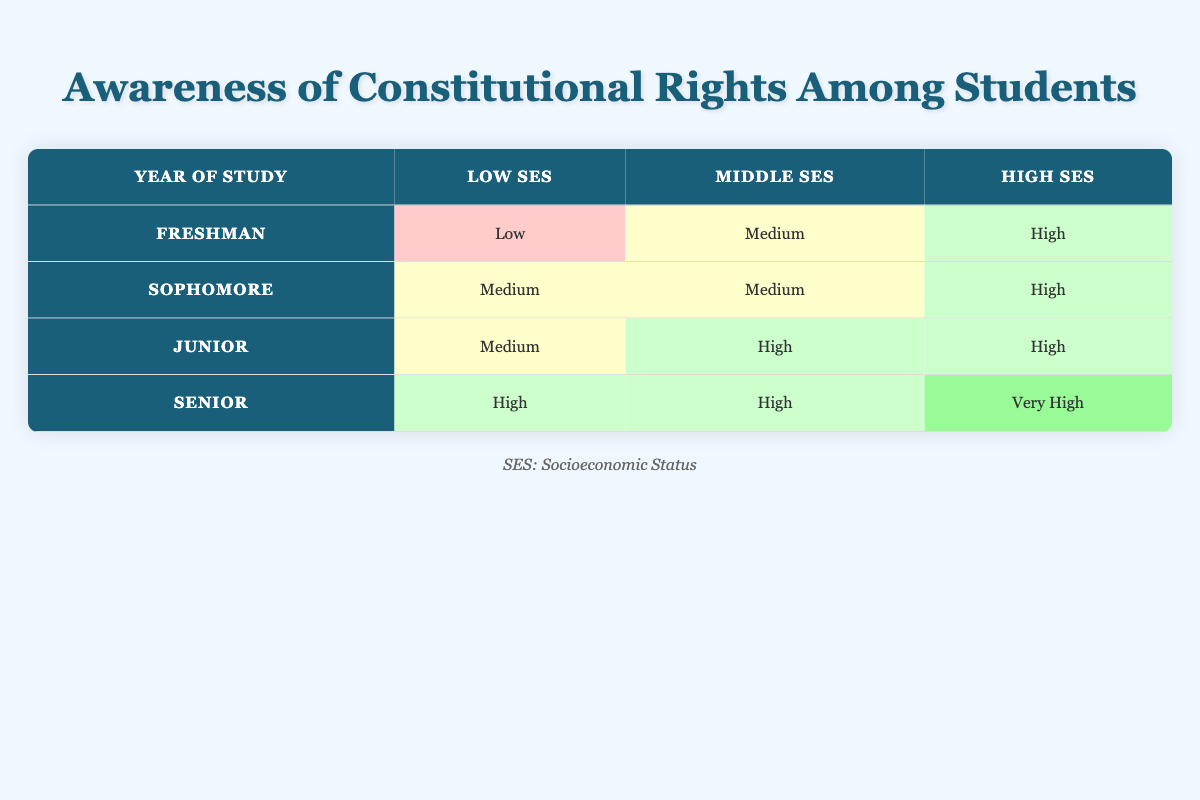What is the awareness level of Freshman students from Low socioeconomic status? According to the table, the awareness level for Freshman students from Low socioeconomic status is classified as "Low".
Answer: Low Which year of study has the highest awareness level for students from High socioeconomic status? In the table, we see that Senior students have an awareness level of "Very High" for High socioeconomic status, which is higher than the levels for Freshman and Junior students.
Answer: Senior How many socioeconomic statuses have a Medium awareness level in total? The table indicates that Freshman (Middle), Sophomore (Low), and both Sophomore (Middle) and Junior (Low) statuses exhibit Medium awareness levels, totaling four instances where the awareness level is Medium.
Answer: Four Is the awareness level for Sophomore students from High socioeconomic status higher than that for Freshman students from Middle socioeconomic status? Yes, the awareness level for Sophomore students from High socioeconomic status is "High", whereas the Freshman students from Middle socioeconomic status have an awareness level labeled as "Medium".
Answer: Yes What is the average awareness level for Junior students? The Junior students have an awareness level comprised of two "Medium" and one "High". In circumstances where "Medium" could be assumed as 1 and "High" as 2, the average can be calculated as (1 + 1 + 2) / 3 = 1.33, translating to an average level closer to "Medium".
Answer: Medium 